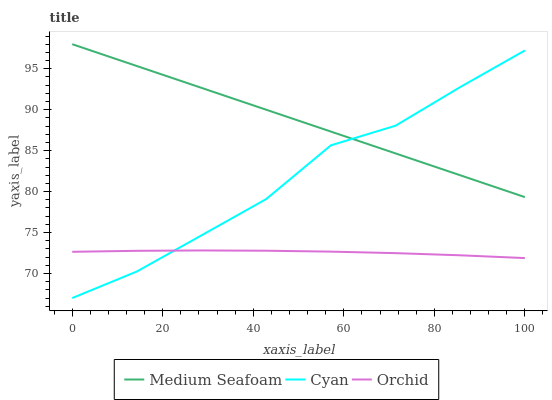Does Orchid have the minimum area under the curve?
Answer yes or no. Yes. Does Medium Seafoam have the maximum area under the curve?
Answer yes or no. Yes. Does Medium Seafoam have the minimum area under the curve?
Answer yes or no. No. Does Orchid have the maximum area under the curve?
Answer yes or no. No. Is Medium Seafoam the smoothest?
Answer yes or no. Yes. Is Cyan the roughest?
Answer yes or no. Yes. Is Orchid the smoothest?
Answer yes or no. No. Is Orchid the roughest?
Answer yes or no. No. Does Cyan have the lowest value?
Answer yes or no. Yes. Does Orchid have the lowest value?
Answer yes or no. No. Does Medium Seafoam have the highest value?
Answer yes or no. Yes. Does Orchid have the highest value?
Answer yes or no. No. Is Orchid less than Medium Seafoam?
Answer yes or no. Yes. Is Medium Seafoam greater than Orchid?
Answer yes or no. Yes. Does Cyan intersect Medium Seafoam?
Answer yes or no. Yes. Is Cyan less than Medium Seafoam?
Answer yes or no. No. Is Cyan greater than Medium Seafoam?
Answer yes or no. No. Does Orchid intersect Medium Seafoam?
Answer yes or no. No. 